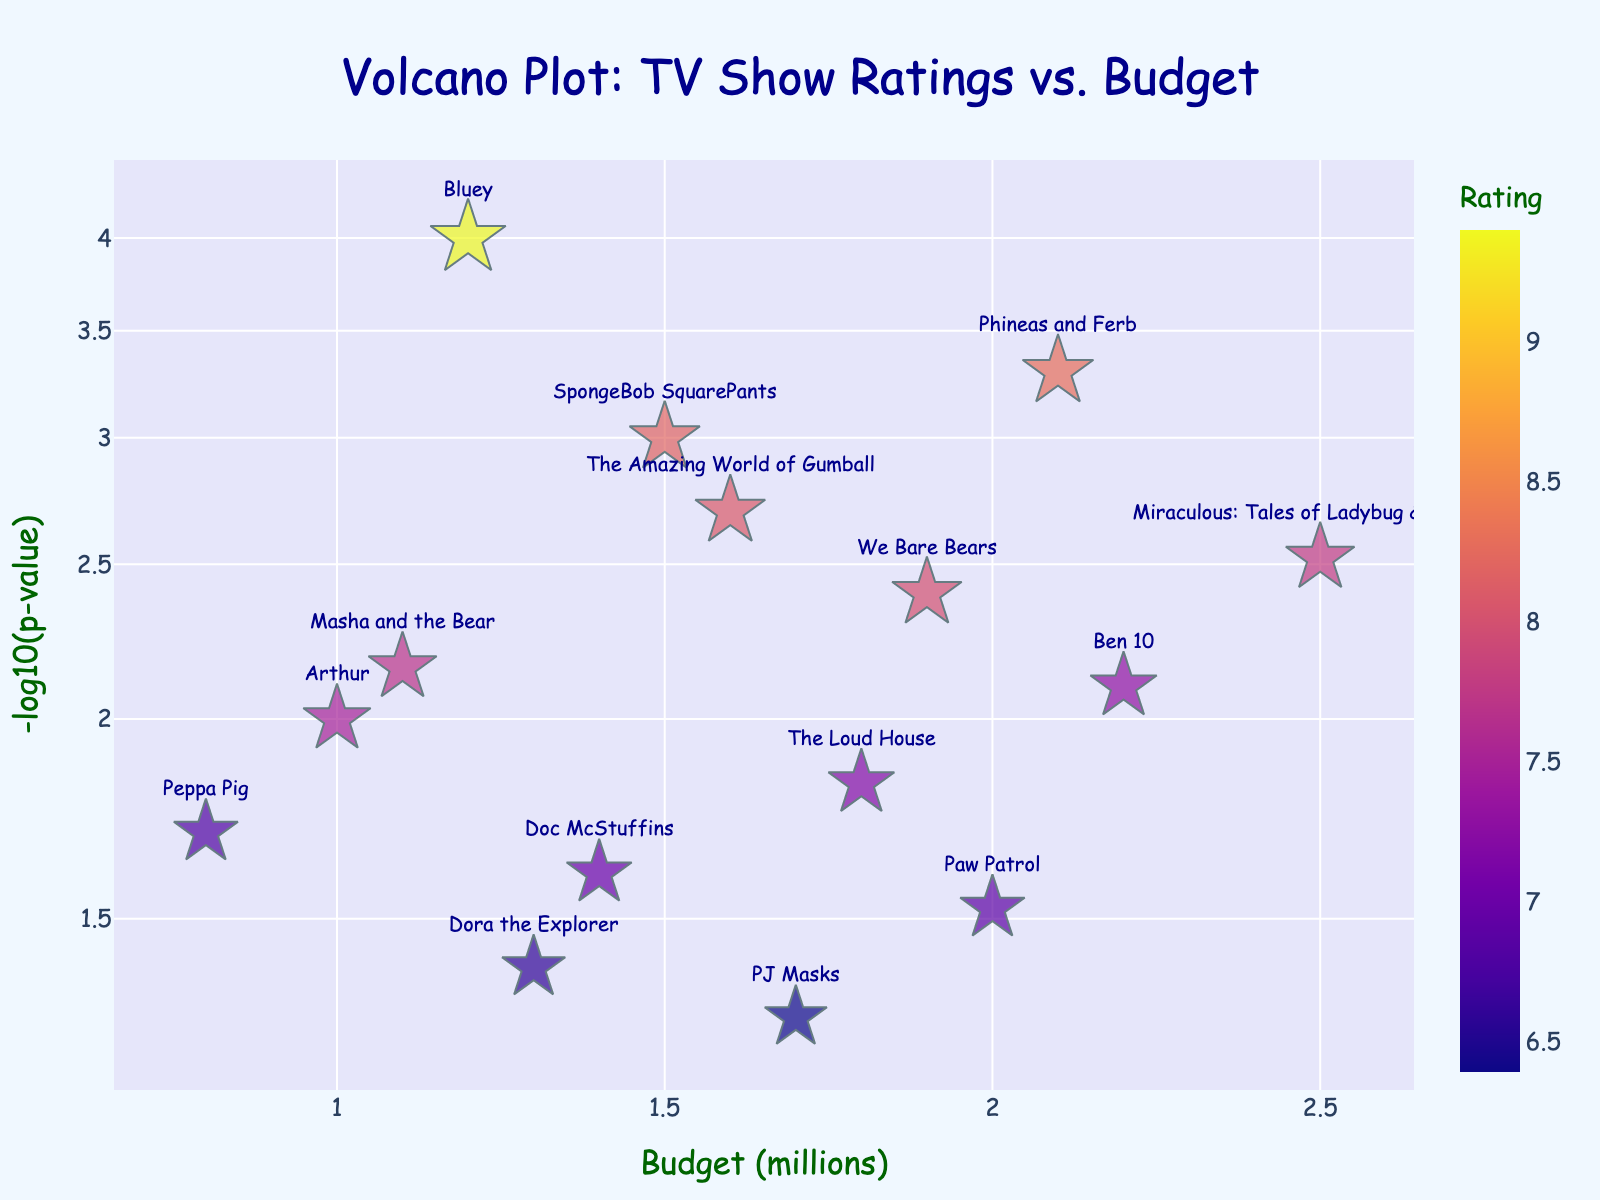What's the title of the plot? The title of the plot is displayed prominently at the top center. It reads "Volcano Plot: TV Show Ratings vs. Budget".
Answer: Volcano Plot: TV Show Ratings vs. Budget How many TV shows are plotted in the figure? Each dot in the plot represents a TV show. Counting the total number of dots gives us the total number of shows.
Answer: 15 Which show has the highest rating? The size of the dots represents the rating of the shows. The largest dot appears next to the label "Bluey".
Answer: Bluey What does the y-axis represent? The y-axis label reads "-log10(p-value)", which represents the negative logarithm to base 10 of the p-value for each show.
Answer: -log10(p-value) Which show has the highest budget? The x-axis represents the budget in millions, and the show positioned furthest to the right is "Miraculous: Tales of Ladybug & Cat Noir".
Answer: Miraculous: Tales of Ladybug & Cat Noir Which two shows have similar budgets but different ratings? By examining the positions of the dots on the x-axis, "SpongeBob SquarePants" and "PJ Masks" have similar budget values around 1.5 to 1.7 million, but have quite different dot sizes, indicating different ratings.
Answer: SpongeBob SquarePants and PJ Masks Which show has a budget of 1.2 million and how does it perform in terms of rating and p-value? From the x-axis, locate the dot that aligns with 1.2 million. The text label shows "Bluey". The color and size indicate it has a high rating (9.4), and its y-axis position shows a low p-value (0.0001).
Answer: Bluey Is there a correlation between budget and p-value? Observe the trend in the positions of the dots. There is no clear, consistent trend that suggests a direct correlation between higher budgets leading to significantly higher or lower p-values.
Answer: No clear correlation Which show has the most significant p-value? The most significant p-value corresponds to the highest -log10(p-value), which is located at the top of the y-axis. "Bluey" has the highest -log10(p-value).
Answer: Bluey What are the budget ranges for the shows rated between 7 and 8? Find the dot sizes that correspond to ratings between 7 and 8 and observe their positions on the x-axis. They range from approximately 1.0 million (Arthur) to 2.5 million (Miraculous: Tales of Ladybug & Cat Noir).
Answer: 1.0 million to 2.5 million 